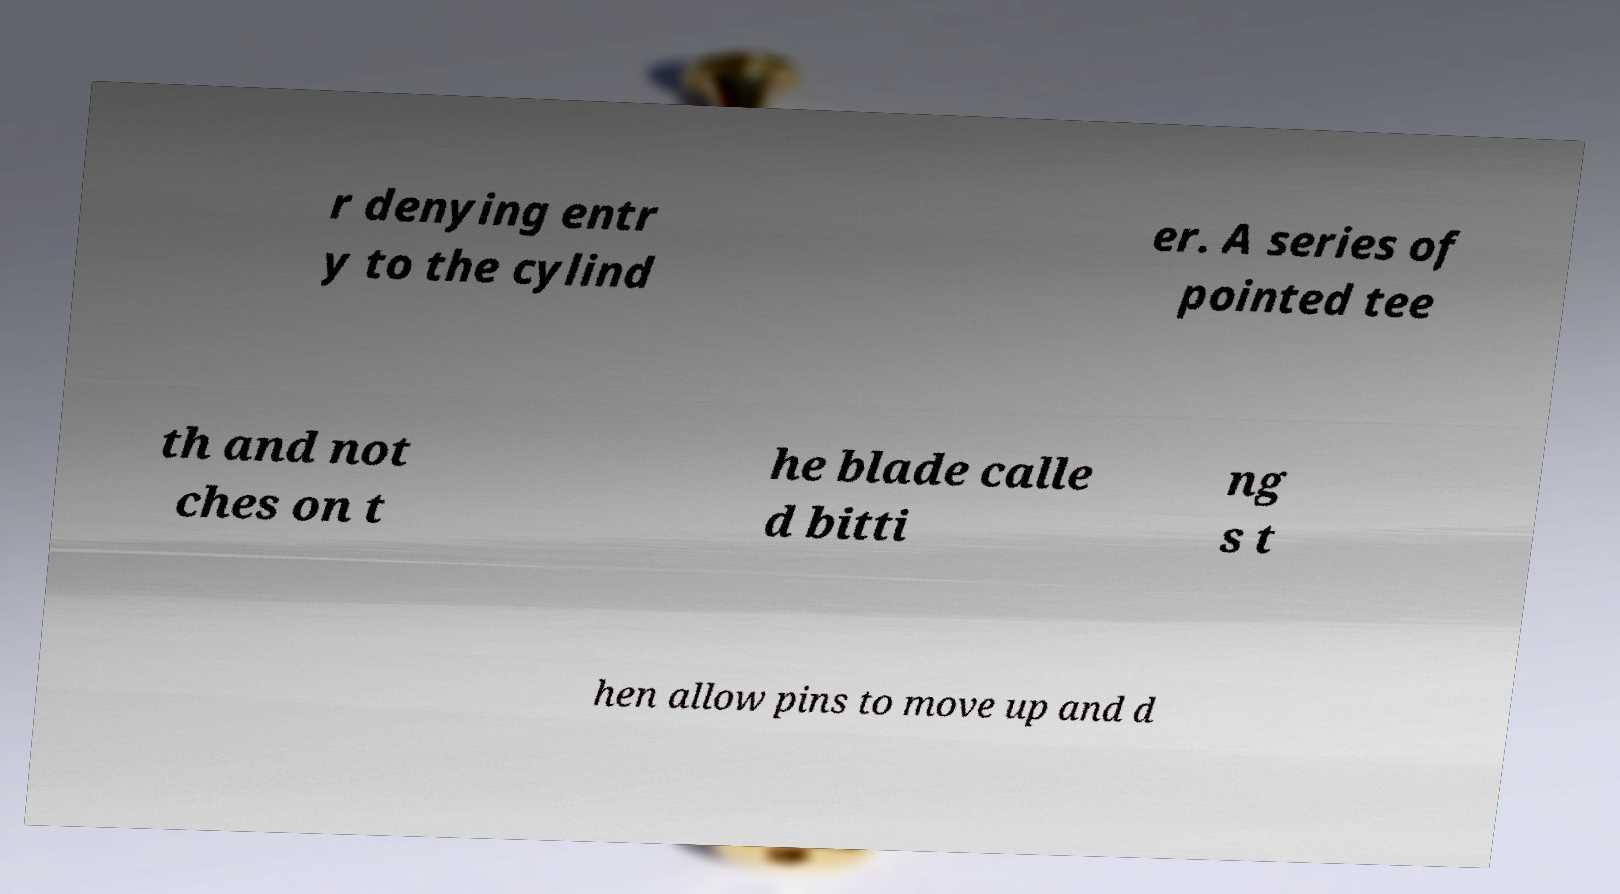Please read and relay the text visible in this image. What does it say? r denying entr y to the cylind er. A series of pointed tee th and not ches on t he blade calle d bitti ng s t hen allow pins to move up and d 